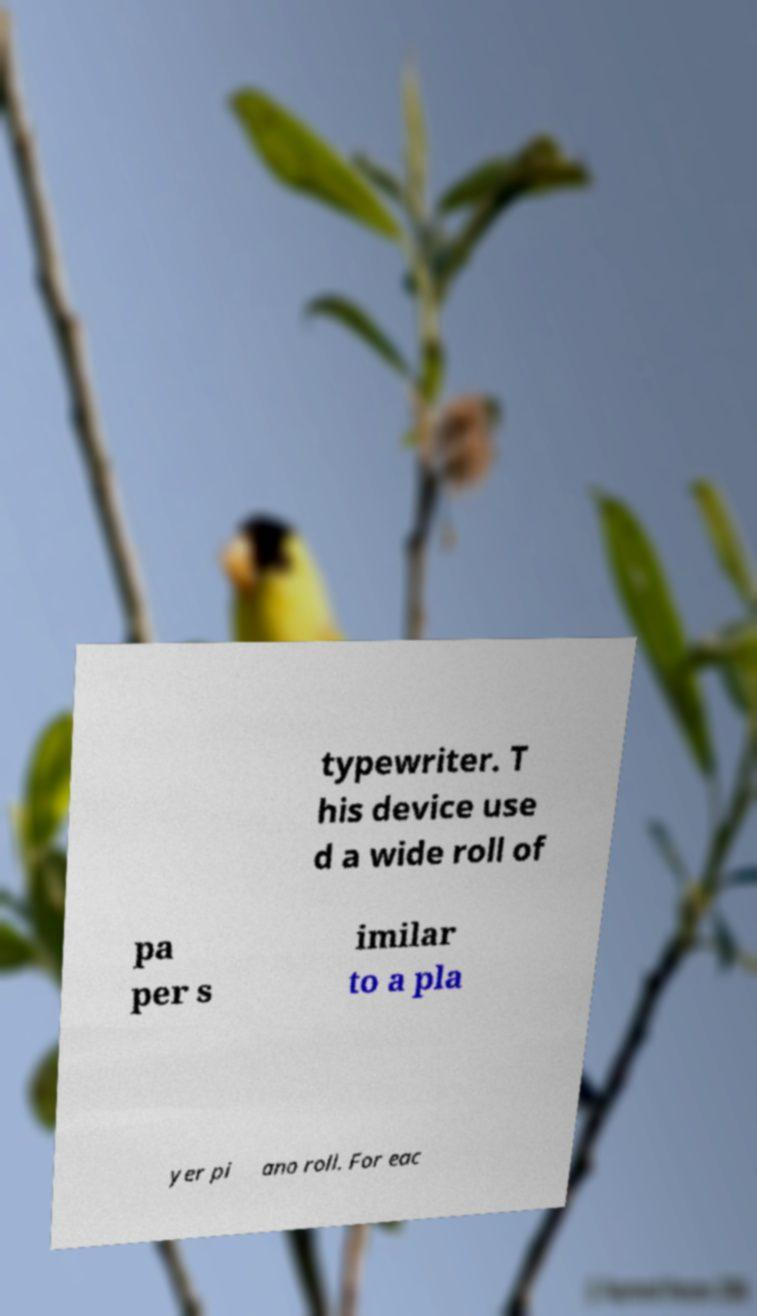For documentation purposes, I need the text within this image transcribed. Could you provide that? typewriter. T his device use d a wide roll of pa per s imilar to a pla yer pi ano roll. For eac 